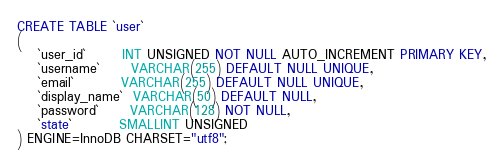Convert code to text. <code><loc_0><loc_0><loc_500><loc_500><_SQL_>CREATE TABLE `user`
(
    `user_id`       INT UNSIGNED NOT NULL AUTO_INCREMENT PRIMARY KEY,
    `username`      VARCHAR(255) DEFAULT NULL UNIQUE,
    `email`         VARCHAR(255) DEFAULT NULL UNIQUE,
    `display_name`  VARCHAR(50) DEFAULT NULL,
    `password`      VARCHAR(128) NOT NULL,
    `state`         SMALLINT UNSIGNED
) ENGINE=InnoDB CHARSET="utf8";
</code> 